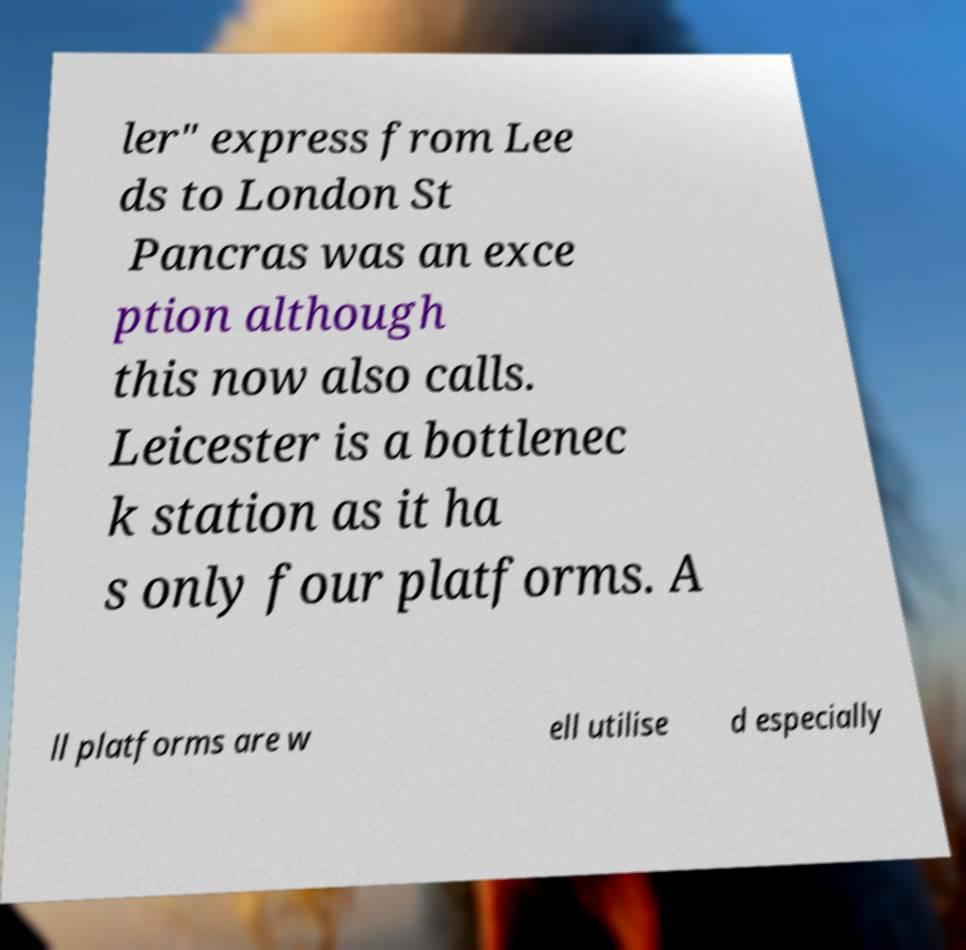Can you accurately transcribe the text from the provided image for me? ler" express from Lee ds to London St Pancras was an exce ption although this now also calls. Leicester is a bottlenec k station as it ha s only four platforms. A ll platforms are w ell utilise d especially 